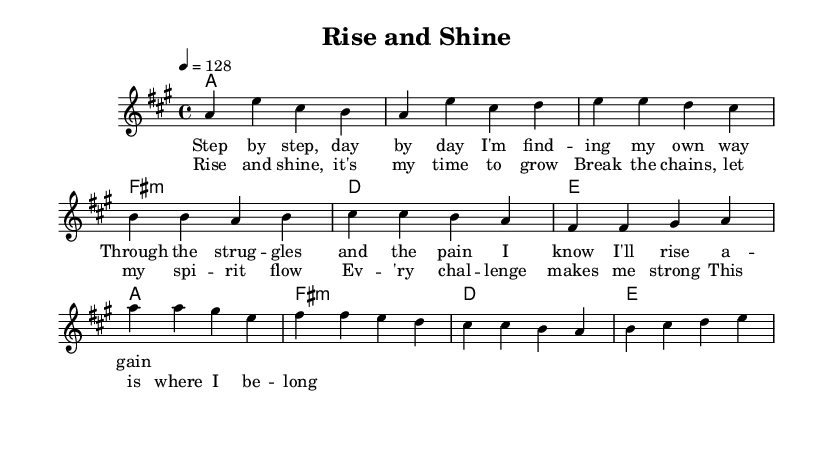What is the key signature of this music? The key signature is A major, which contains three sharps (F#, C#, and G#). We can identify the key signature at the beginning of the music sheet where the sharps are displayed.
Answer: A major What is the time signature of this music? The time signature is 4/4, noted at the beginning of the score. It indicates there are four beats in a measure and the quarter note gets one beat.
Answer: 4/4 What is the tempo marking for this piece? The tempo marking indicates a speed of 128 beats per minute, which is specified in the tempo section. The number 4 equals 128 suggests a moderate pace.
Answer: 128 How many measures are in the chorus section? The chorus is made up of four measures, which we can count by looking at the rhythmic notation within the chorus section.
Answer: 4 Which chord appears in the first two measures of the intro? The first two measures of the intro show the A major chord, as indicated under the harmonies section with an "a1" chord notation.
Answer: A major What is the primary theme of the lyrics? The primary theme of the lyrics focuses on personal growth and overcoming challenges. This is evident from phrases in both the verse and chorus that emphasize rising again and spiritual flow.
Answer: Personal growth What is the structure of the song? The structure of the song is verse-chorus format. This can be inferred from the clear sections labeled as 'Verse' and 'Chorus' in the sheet music, indicating the alternate pattern.
Answer: Verse-Chorus 